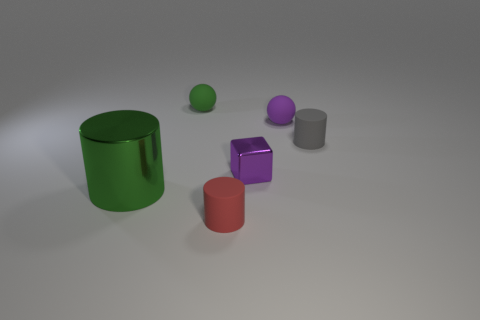What can you infer about the light source in this scene? The shadows cast by the objects indicate that the light source is positioned to the upper right of the scene, likely out of the frame. 